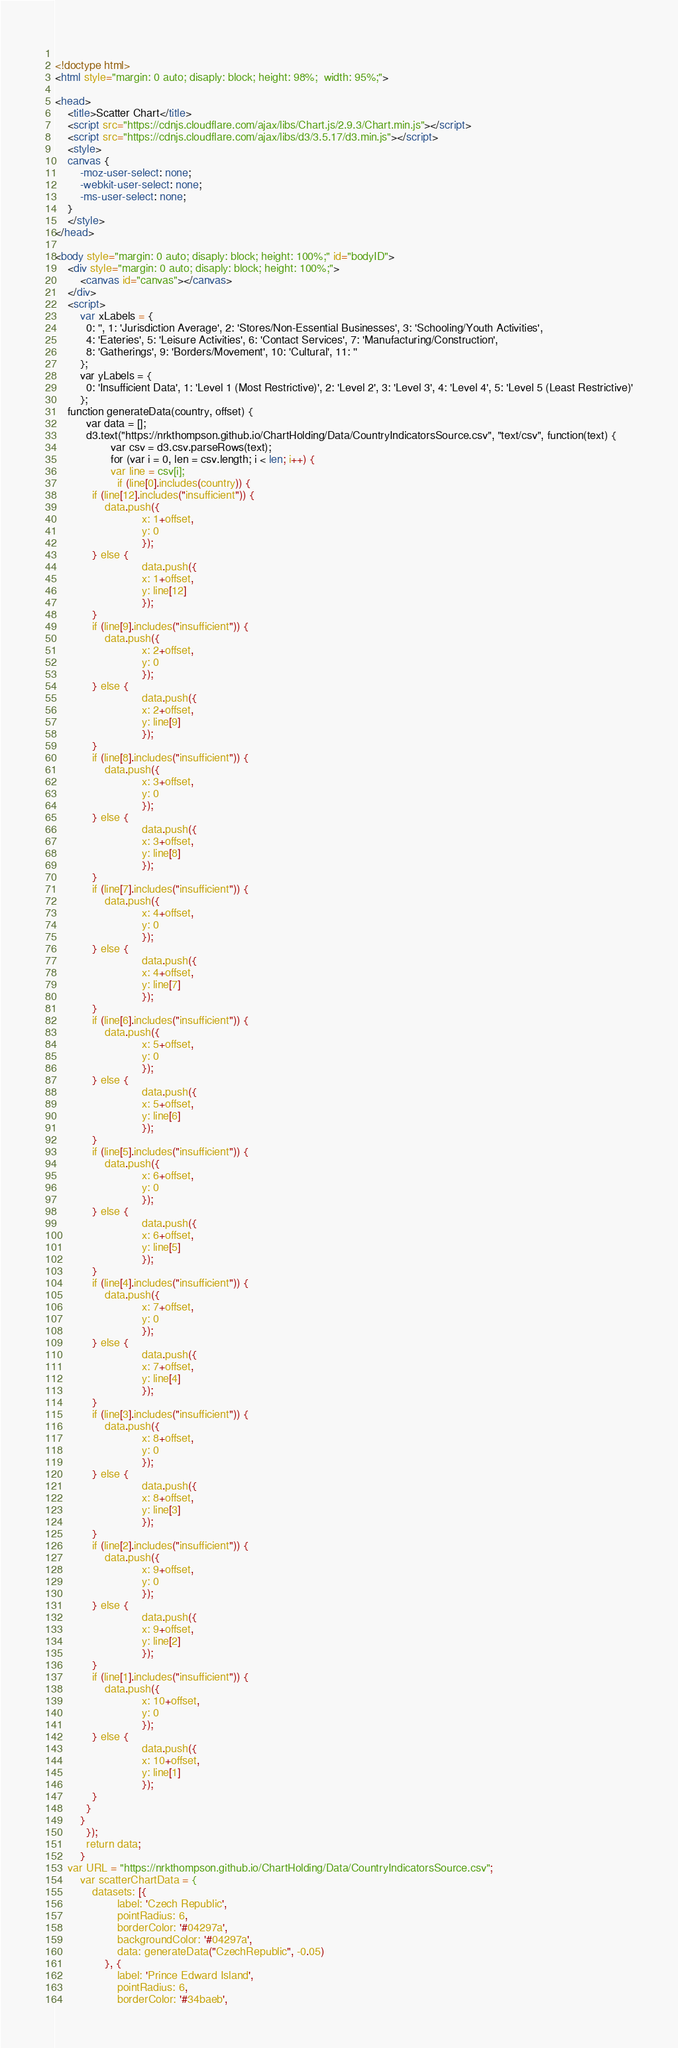Convert code to text. <code><loc_0><loc_0><loc_500><loc_500><_HTML_>  
<!doctype html>
<html style="margin: 0 auto; disaply: block; height: 98%;  width: 95%;">

<head>
	<title>Scatter Chart</title>
	<script src="https://cdnjs.cloudflare.com/ajax/libs/Chart.js/2.9.3/Chart.min.js"></script>
	<script src="https://cdnjs.cloudflare.com/ajax/libs/d3/3.5.17/d3.min.js"></script>
	<style>
	canvas {
		-moz-user-select: none;
		-webkit-user-select: none;
		-ms-user-select: none;
	}
	</style>
</head>

<body style="margin: 0 auto; disaply: block; height: 100%;" id="bodyID">
	<div style="margin: 0 auto; disaply: block; height: 100%;">
		<canvas id="canvas"></canvas>
	</div>
	<script>
	    var xLabels = {
	      0: '', 1: 'Jurisdiction Average', 2: 'Stores/Non-Essential Businesses', 3: 'Schooling/Youth Activities',
	      4: 'Eateries', 5: 'Leisure Activities', 6: 'Contact Services', 7: 'Manufacturing/Construction',
	      8: 'Gatherings', 9: 'Borders/Movement', 10: 'Cultural', 11: ''
	    };
	    var yLabels = {
	      0: 'Insufficient Data', 1: 'Level 1 (Most Restrictive)', 2: 'Level 2', 3: 'Level 3', 4: 'Level 4', 5: 'Level 5 (Least Restrictive)'
	    };
    function generateData(country, offset) {
          var data = [];
          d3.text("https://nrkthompson.github.io/ChartHolding/Data/CountryIndicatorsSource.csv", "text/csv", function(text) {
                  var csv = d3.csv.parseRows(text);
                  for (var i = 0, len = csv.length; i < len; i++) {
                  var line = csv[i];
                    if (line[0].includes(country)) {
			if (line[12].includes("insufficient")) {
				data.push({
                        	x: 1+offset,
                        	y: 0
                        	});
			} else {
                        	data.push({
                        	x: 1+offset,
                        	y: line[12]
                        	});
			}
			if (line[9].includes("insufficient")) {
				data.push({
                        	x: 2+offset,
                        	y: 0
                        	});
			} else {
                        	data.push({
                        	x: 2+offset,
                        	y: line[9]
                        	});
			}
			if (line[8].includes("insufficient")) {
				data.push({
                        	x: 3+offset,
                        	y: 0
                        	});
			} else {
                        	data.push({
                        	x: 3+offset,
                        	y: line[8]
                        	});
			}
			if (line[7].includes("insufficient")) {
				data.push({
                        	x: 4+offset,
                        	y: 0
                        	});
			} else {
                        	data.push({
                        	x: 4+offset,
                        	y: line[7]
                        	});
			}
			if (line[6].includes("insufficient")) {
				data.push({
                        	x: 5+offset,
                        	y: 0
                        	});
			} else {
                        	data.push({
                        	x: 5+offset,
                        	y: line[6]
                        	});
			}
			if (line[5].includes("insufficient")) {
				data.push({
                        	x: 6+offset,
                        	y: 0
                        	});
			} else {
                        	data.push({
                        	x: 6+offset,
                        	y: line[5]
                        	});
			}
			if (line[4].includes("insufficient")) {
				data.push({
                        	x: 7+offset,
                        	y: 0
                        	});
			} else {
                        	data.push({
                        	x: 7+offset,
                        	y: line[4]
                        	});
			}
			if (line[3].includes("insufficient")) {
				data.push({
                        	x: 8+offset,
                        	y: 0
                        	});
			} else {
                        	data.push({
                        	x: 8+offset,
                        	y: line[3]
                        	});
			}
			if (line[2].includes("insufficient")) {
				data.push({
                        	x: 9+offset,
                        	y: 0
                        	});
			} else {
                        	data.push({
                        	x: 9+offset,
                        	y: line[2]
                        	});
			}
			if (line[1].includes("insufficient")) {
				data.push({
                        	x: 10+offset,
                        	y: 0
                        	});
			} else {
                        	data.push({
                        	x: 10+offset,
                        	y: line[1]
                        	});
			}
		  }
		}
          });
          return data;
        }
    var URL = "https://nrkthompson.github.io/ChartHolding/Data/CountryIndicatorsSource.csv";
		var scatterChartData = {
			datasets: [{
					label: 'Czech Republic',
					pointRadius: 6,
					borderColor: '#04297a',
					backgroundColor: '#04297a',
					data: generateData("CzechRepublic", -0.05)
				}, {
					label: 'Prince Edward Island',
					pointRadius: 6,
					borderColor: '#34baeb',</code> 